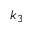<formula> <loc_0><loc_0><loc_500><loc_500>k _ { 3 }</formula> 